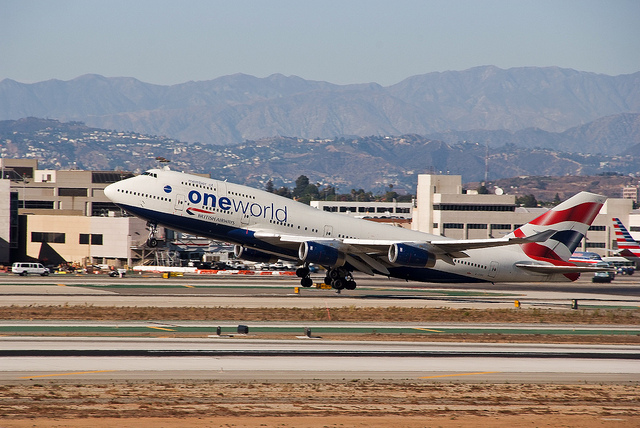How many people are on the train platform? The initial question seems to be based on an incorrect observation, as the image depicts a 'one world' airline airplane taking off and not a train platform. Therefore, the question cannot be accurately answered based on this image. 